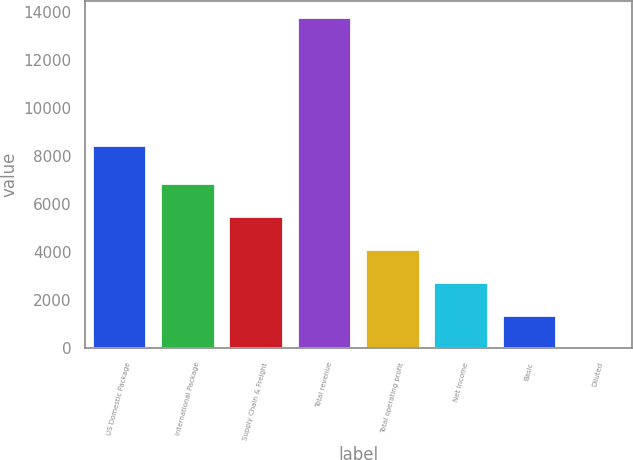Convert chart. <chart><loc_0><loc_0><loc_500><loc_500><bar_chart><fcel>US Domestic Package<fcel>International Package<fcel>Supply Chain & Freight<fcel>Total revenue<fcel>Total operating profit<fcel>Net Income<fcel>Basic<fcel>Diluted<nl><fcel>8488<fcel>6889.98<fcel>5512.18<fcel>13779<fcel>4134.38<fcel>2756.58<fcel>1378.78<fcel>0.98<nl></chart> 